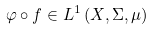Convert formula to latex. <formula><loc_0><loc_0><loc_500><loc_500>\varphi \circ f \in L ^ { 1 } \left ( X , \Sigma , \mu \right )</formula> 